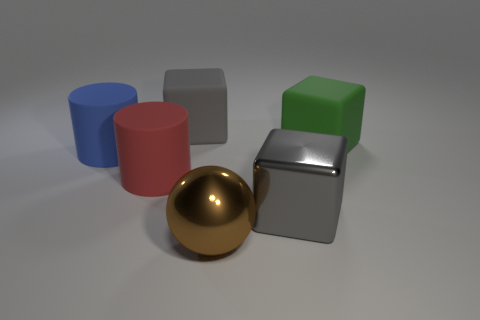There is a cube in front of the green matte block; is it the same color as the block left of the gray shiny thing?
Provide a short and direct response. Yes. The rubber block that is the same color as the large shiny cube is what size?
Provide a succinct answer. Large. What is the material of the thing that is the same color as the metallic cube?
Offer a terse response. Rubber. How many large objects are gray matte cylinders or rubber cylinders?
Your answer should be very brief. 2. What shape is the rubber object behind the big green rubber thing?
Your answer should be compact. Cube. Is there another big cube of the same color as the shiny block?
Provide a short and direct response. Yes. Does the gray thing that is in front of the blue rubber object have the same size as the rubber cube in front of the gray rubber thing?
Give a very brief answer. Yes. Are there more big red rubber cylinders in front of the big gray rubber block than green rubber cubes on the left side of the green object?
Offer a very short reply. Yes. Is there a large cube that has the same material as the brown ball?
Your answer should be very brief. Yes. What material is the thing that is right of the large brown shiny ball and in front of the red cylinder?
Provide a short and direct response. Metal. 